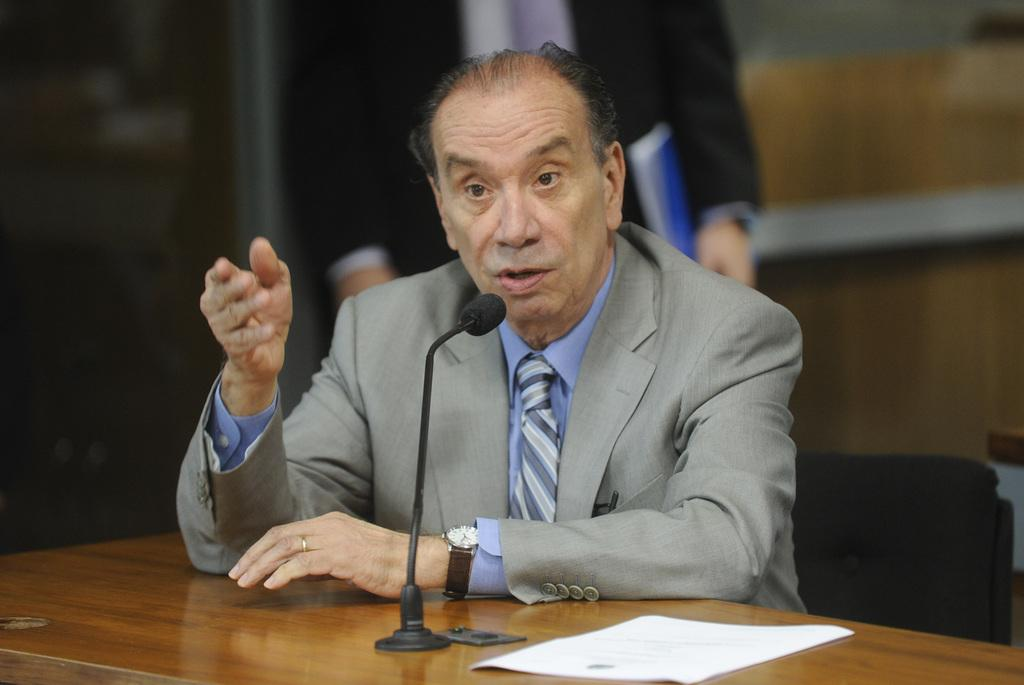What is the man in the image doing? The man is sitting in a chair and speaking into a microphone. What is the man touching in the image? The man has his hand on a table. Who else is present in the image? There is another person in the image. What object can be seen on the table in the image? There is a paper visible on the table. What type of jam is being served at the event in the image? There is no mention of jam or any event in the image; it only shows a man sitting in a chair, speaking into a microphone, and a table with a paper on it. 